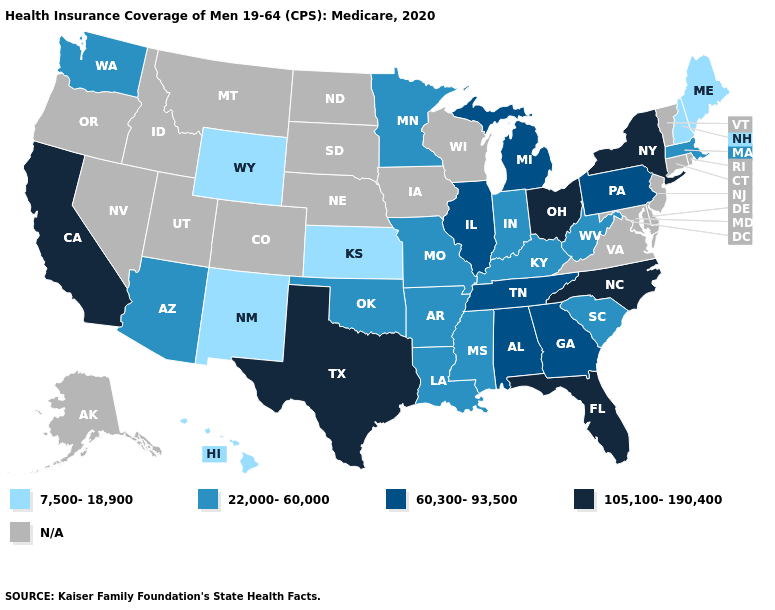What is the value of New Hampshire?
Be succinct. 7,500-18,900. Which states have the lowest value in the South?
Give a very brief answer. Arkansas, Kentucky, Louisiana, Mississippi, Oklahoma, South Carolina, West Virginia. Does Michigan have the highest value in the MidWest?
Be succinct. No. What is the lowest value in states that border Arkansas?
Give a very brief answer. 22,000-60,000. Name the states that have a value in the range N/A?
Write a very short answer. Alaska, Colorado, Connecticut, Delaware, Idaho, Iowa, Maryland, Montana, Nebraska, Nevada, New Jersey, North Dakota, Oregon, Rhode Island, South Dakota, Utah, Vermont, Virginia, Wisconsin. Name the states that have a value in the range N/A?
Quick response, please. Alaska, Colorado, Connecticut, Delaware, Idaho, Iowa, Maryland, Montana, Nebraska, Nevada, New Jersey, North Dakota, Oregon, Rhode Island, South Dakota, Utah, Vermont, Virginia, Wisconsin. What is the value of Wisconsin?
Give a very brief answer. N/A. Name the states that have a value in the range 60,300-93,500?
Answer briefly. Alabama, Georgia, Illinois, Michigan, Pennsylvania, Tennessee. What is the value of Mississippi?
Quick response, please. 22,000-60,000. What is the value of Illinois?
Write a very short answer. 60,300-93,500. What is the value of South Carolina?
Give a very brief answer. 22,000-60,000. 